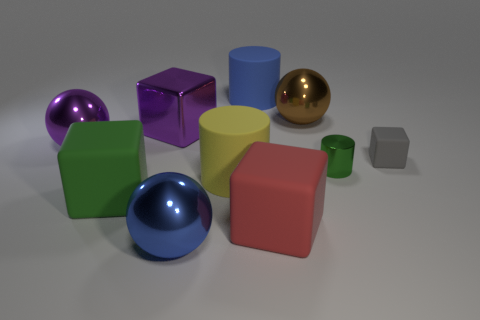Subtract 1 cubes. How many cubes are left? 3 Subtract all red cylinders. Subtract all blue cubes. How many cylinders are left? 3 Subtract all balls. How many objects are left? 7 Add 9 large purple shiny spheres. How many large purple shiny spheres exist? 10 Subtract 0 green balls. How many objects are left? 10 Subtract all tiny things. Subtract all big green blocks. How many objects are left? 7 Add 3 yellow cylinders. How many yellow cylinders are left? 4 